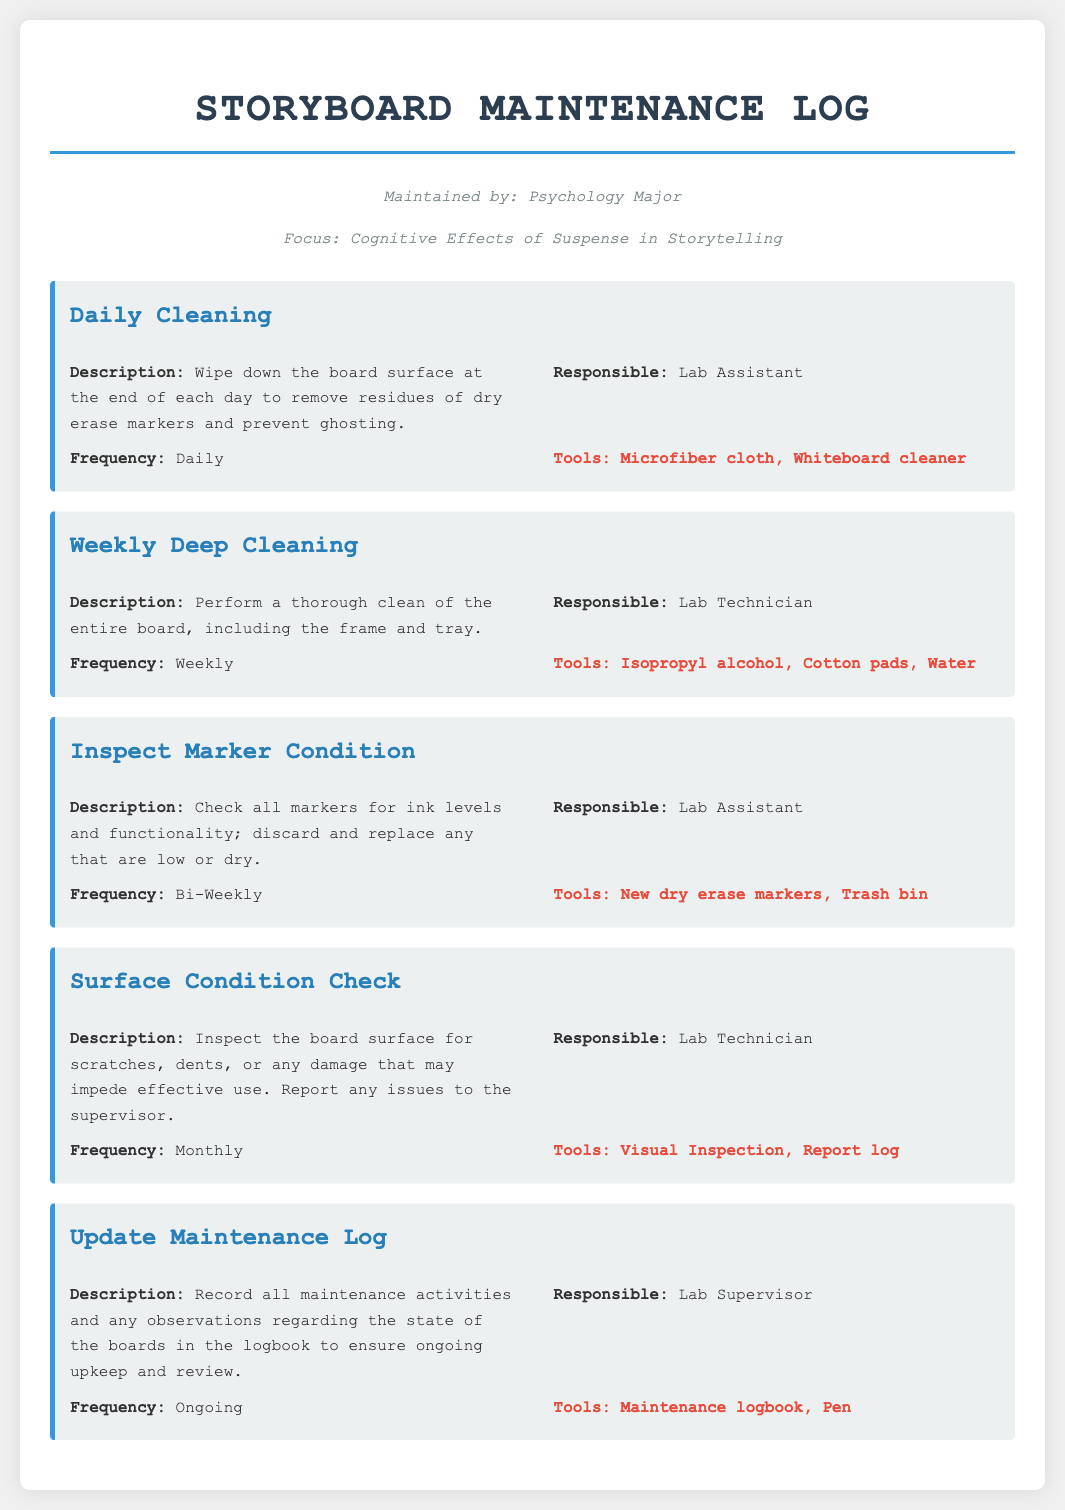What is the frequency of Daily Cleaning? The frequency of Daily Cleaning is mentioned directly in the document as 'Daily'.
Answer: Daily Who is responsible for updating the Maintenance Log? The document specifies that the Lab Supervisor is responsible for this task.
Answer: Lab Supervisor What tools are needed for Weekly Deep Cleaning? The tools required for Weekly Deep Cleaning include Isopropyl alcohol, Cotton pads, and Water.
Answer: Isopropyl alcohol, Cotton pads, Water How often should the Surface Condition Check be performed? The document states that the frequency for Surface Condition Check is 'Monthly'.
Answer: Monthly What is the description of the Inspect Marker Condition activity? The description details checking all markers for ink levels and replacing any that are low or dry.
Answer: Check all markers for ink levels and functionality; discard and replace any that are low or dry Why is updating the Maintenance Log considered an ongoing task? The log is meant to ensure ongoing upkeep and review of the boards, making it essential to be updated continuously.
Answer: Ongoing What is the purpose of the Daily Cleaning activity? The purpose is to wipe down the board surface to remove residues and prevent ghosting.
Answer: Remove residues of dry erase markers and prevent ghosting What color is used for the activity titles in the log? The color of the activity titles is specified as '#2980b9' within the styling of the document.
Answer: #2980b9 